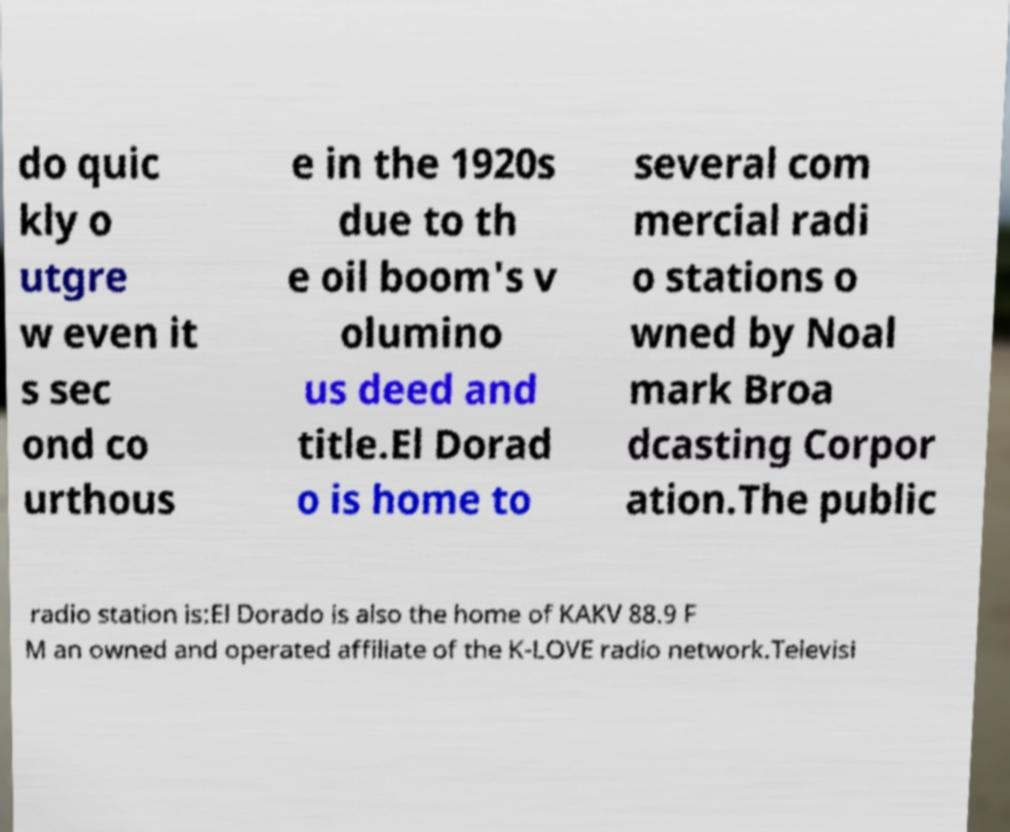For documentation purposes, I need the text within this image transcribed. Could you provide that? do quic kly o utgre w even it s sec ond co urthous e in the 1920s due to th e oil boom's v olumino us deed and title.El Dorad o is home to several com mercial radi o stations o wned by Noal mark Broa dcasting Corpor ation.The public radio station is:El Dorado is also the home of KAKV 88.9 F M an owned and operated affiliate of the K-LOVE radio network.Televisi 